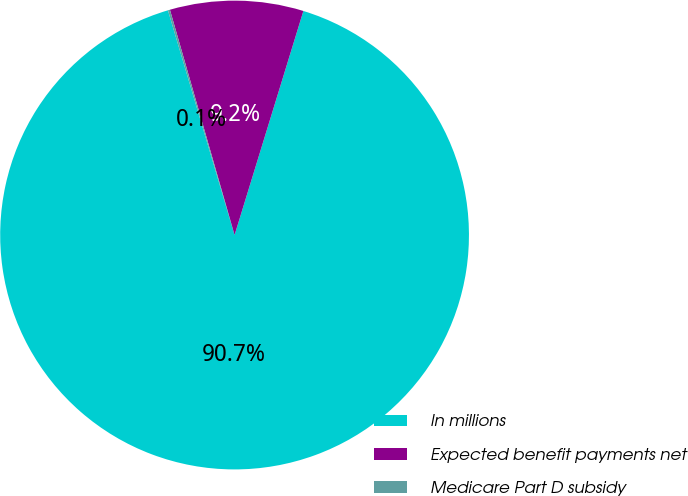<chart> <loc_0><loc_0><loc_500><loc_500><pie_chart><fcel>In millions<fcel>Expected benefit payments net<fcel>Medicare Part D subsidy<nl><fcel>90.68%<fcel>9.19%<fcel>0.14%<nl></chart> 